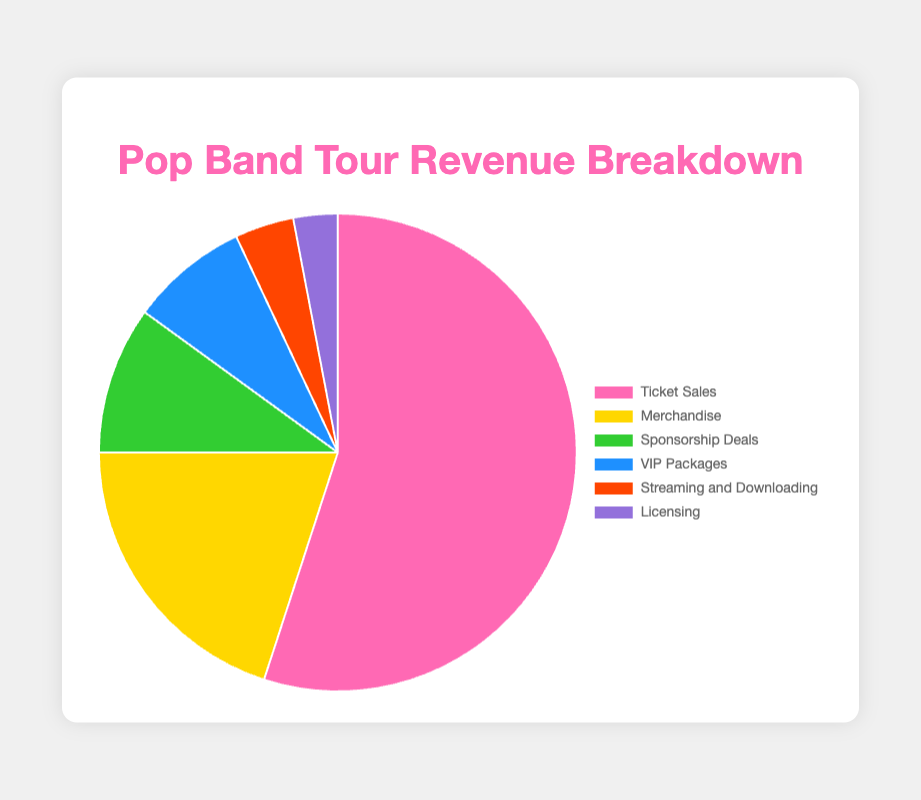What percentage of revenue comes from merchandise and VIP packages combined? Add the percentages of revenue from Merchandise (20%) and VIP Packages (8%). 20 + 8 = 28
Answer: 28% Which revenue source contributes the least to the total revenue? Identify the source with the smallest percentage. Licensing at 3% is the smallest.
Answer: Licensing Is the percentage of revenue from ticket sales greater than the combined percentage of sponsorship deals and licensing? Compare the percentage of revenue from Ticket Sales (55%) to the sum of Sponsorship Deals (10%) and Licensing (3%). 10 + 3 = 13; 55 > 13
Answer: Yes What is the difference in revenue percentage between ticket sales and streaming and downloading? Subtract the percentage of Streaming and Downloading (4%) from Ticket Sales (55%). 55 - 4 = 51
Answer: 51% How many revenue sources have a percentage of 10% or higher? Identify revenue sources with percentages 10% or higher: Ticket Sales (55%), Merchandise (20%), Sponsorship Deals (10%). The count is 3.
Answer: 3 Which revenue source is represented by the yellow color? From the chart's visual attributes, Merchandise is represented by the yellow color.
Answer: Merchandise Are VIP Packages a greater revenue source than Sponsorship Deals? Compare the percentages: VIP Packages (8%) vs. Sponsorship Deals (10%). 8 < 10
Answer: No What is the sum of percentages from the three smallest revenue sources? Add percentages of Licensing (3%), Streaming and Downloading (4%), and VIP Packages (8%). 3 + 4 + 8 = 15
Answer: 15% Which revenue sources have a smaller percentage than merchandise? Identify the revenue sources with percentages smaller than Merchandise (20%): Sponsorship Deals (10%), VIP Packages (8%), Streaming and Downloading (4%), Licensing (3%).
Answer: Sponsorship Deals, VIP Packages, Streaming and Downloading, Licensing 